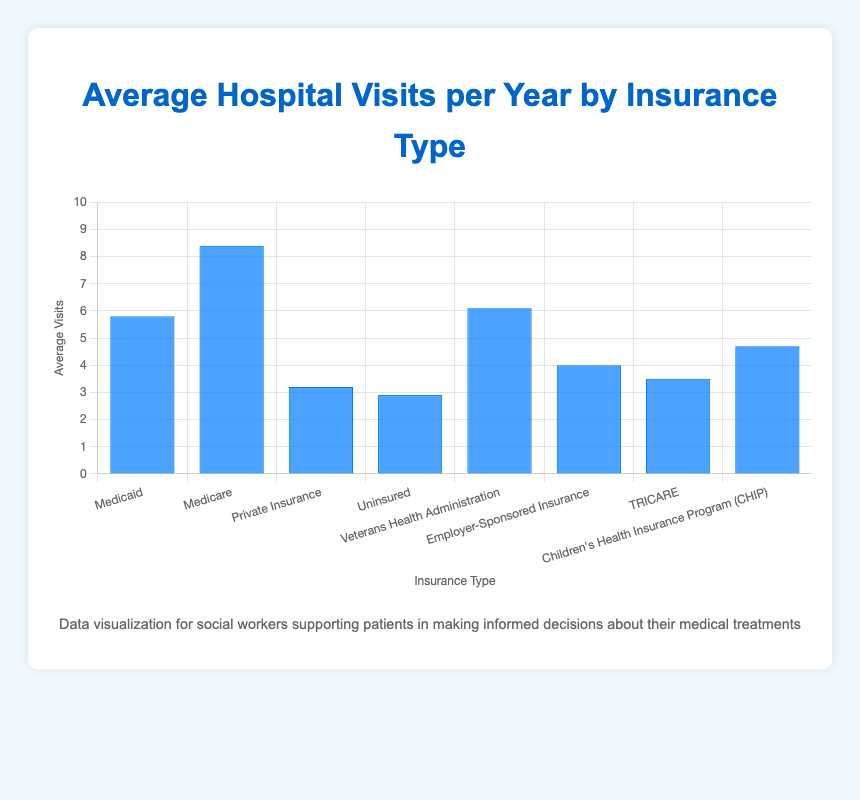How many more average hospital visits per year does Medicare have compared to TRICARE? To find the difference, subtract the average hospital visits per year for TRICARE from Medicare: 8.4 (Medicare) - 3.5 (TRICARE) = 4.9.
Answer: 4.9 Which insurance type has the highest average hospital visits per year? By examining the heights of the bars, the tallest bar represents Medicare with an average of 8.4 hospital visits per year, which is the highest among all types.
Answer: Medicare What is the total average hospital visits per year for Employer-Sponsored Insurance and CHIP combined? Add the average hospital visits per year for these two insurance types: 4.0 (Employer-Sponsored Insurance) + 4.7 (CHIP) = 8.7.
Answer: 8.7 How does the average hospital visits per year for Medicaid compare to that of Private Insurance? By comparing the heights of the bars, Medicaid (5.8) has more average hospital visits per year than Private Insurance (3.2).
Answer: Medicaid has more Which insurance types have fewer average hospital visits per year than Medicaid? By comparing the heights of the bars, the insurance types with fewer average visits than Medicaid (5.8) are Private Insurance (3.2), Uninsured (2.9), Employer-Sponsored Insurance (4.0), TRICARE (3.5), and CHIP (4.7).
Answer: Private Insurance, Uninsured, Employer-Sponsored Insurance, TRICARE, CHIP What is the average of average hospital visits per year across all insurance types? Sum the average visits for each insurance type and divide by the number of insurance types. (5.8 + 8.4 + 3.2 + 2.9 + 6.1 + 4.0 + 3.5 + 4.7) / 8 = 4.825.
Answer: 4.825 What is the difference between the highest and lowest average hospital visits per year? Subtract the lowest average visits (Uninsured, 2.9) from the highest (Medicare, 8.4): 8.4 - 2.9 = 5.5.
Answer: 5.5 If we group Medicaid, Medicare, and Veterans Health Administration together, what is their combined average hospital visits per year? Sum the average hospital visits per year for these three insurance types: 5.8 (Medicaid) + 8.4 (Medicare) + 6.1 (Veterans Health Administration) = 20.3.
Answer: 20.3 